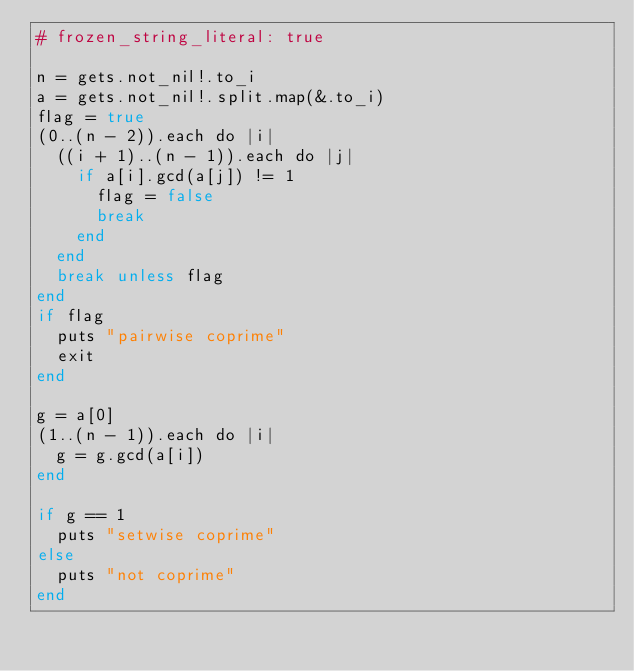Convert code to text. <code><loc_0><loc_0><loc_500><loc_500><_Crystal_># frozen_string_literal: true

n = gets.not_nil!.to_i
a = gets.not_nil!.split.map(&.to_i)
flag = true
(0..(n - 2)).each do |i|
  ((i + 1)..(n - 1)).each do |j|
    if a[i].gcd(a[j]) != 1
      flag = false
      break
    end
  end
  break unless flag
end
if flag
  puts "pairwise coprime"
  exit
end

g = a[0]
(1..(n - 1)).each do |i|
  g = g.gcd(a[i])
end

if g == 1
  puts "setwise coprime"
else
  puts "not coprime"
end
</code> 